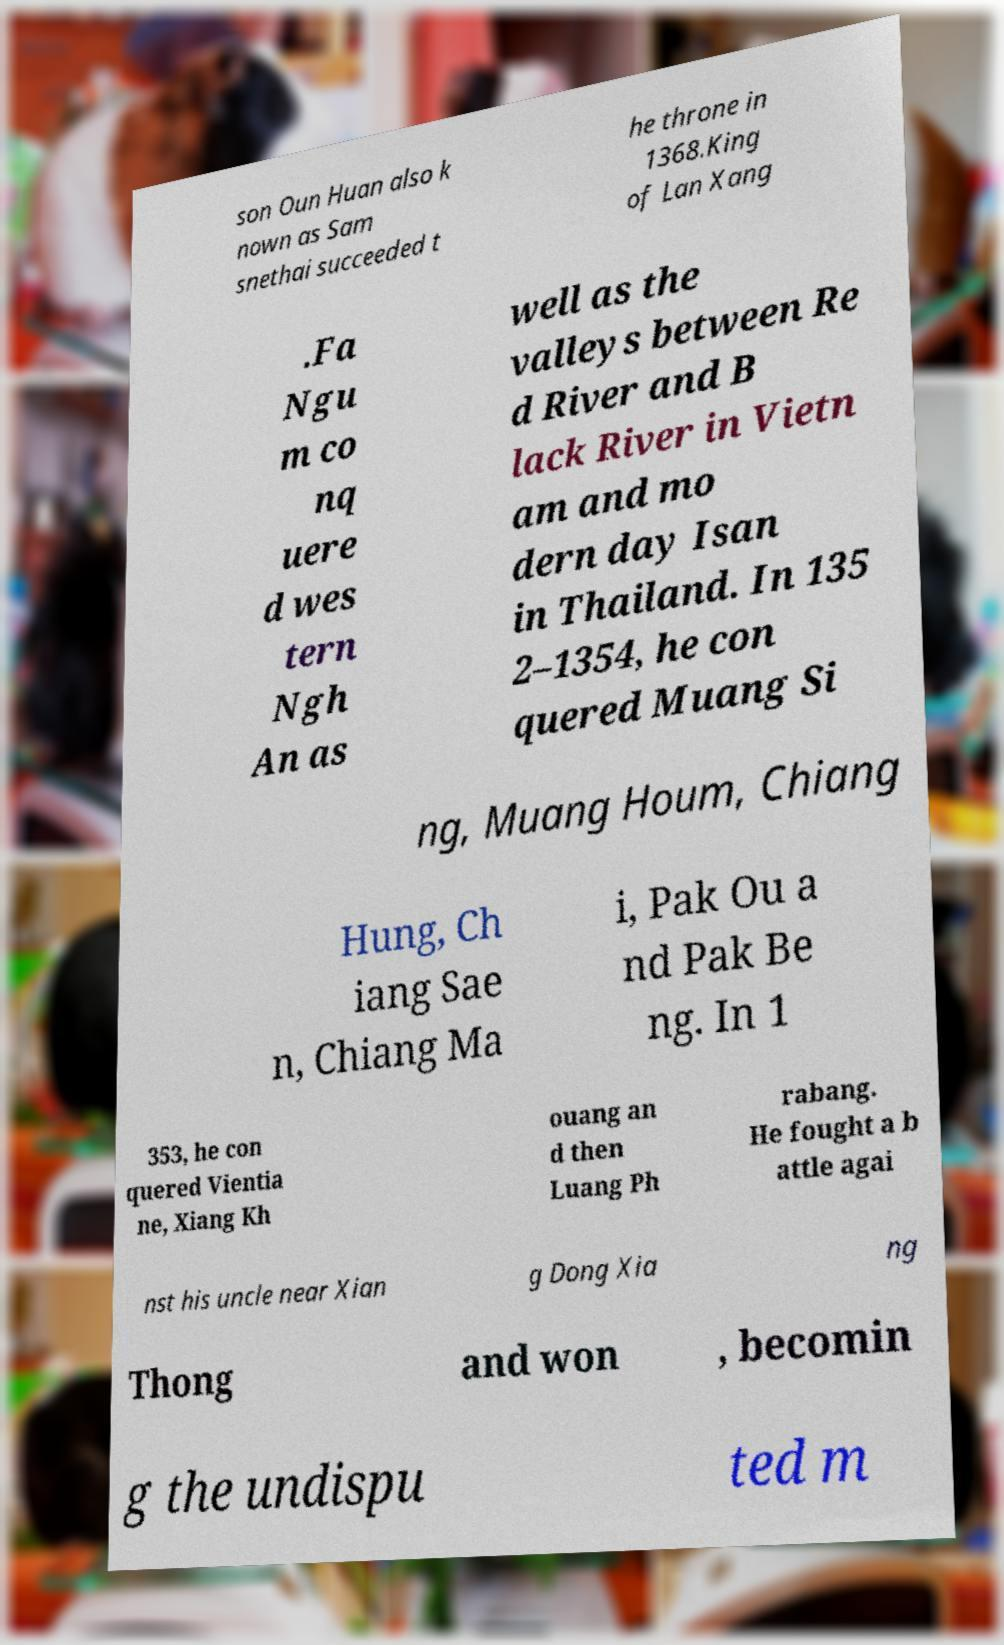There's text embedded in this image that I need extracted. Can you transcribe it verbatim? son Oun Huan also k nown as Sam snethai succeeded t he throne in 1368.King of Lan Xang .Fa Ngu m co nq uere d wes tern Ngh An as well as the valleys between Re d River and B lack River in Vietn am and mo dern day Isan in Thailand. In 135 2–1354, he con quered Muang Si ng, Muang Houm, Chiang Hung, Ch iang Sae n, Chiang Ma i, Pak Ou a nd Pak Be ng. In 1 353, he con quered Vientia ne, Xiang Kh ouang an d then Luang Ph rabang. He fought a b attle agai nst his uncle near Xian g Dong Xia ng Thong and won , becomin g the undispu ted m 